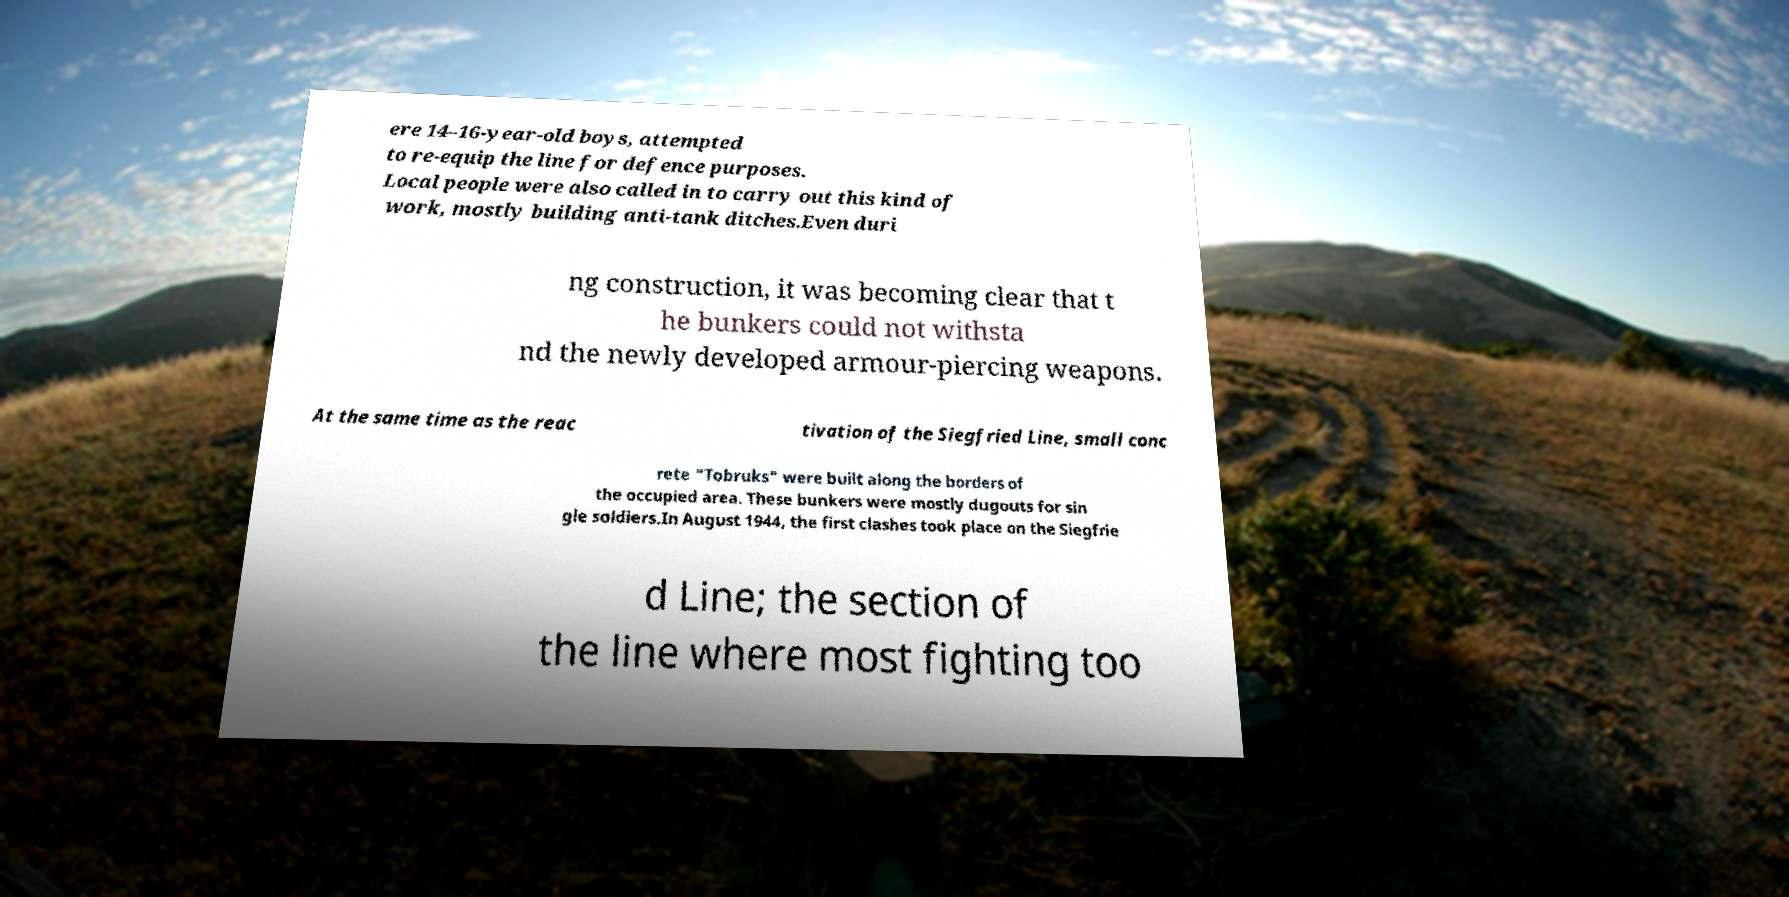Could you assist in decoding the text presented in this image and type it out clearly? ere 14–16-year-old boys, attempted to re-equip the line for defence purposes. Local people were also called in to carry out this kind of work, mostly building anti-tank ditches.Even duri ng construction, it was becoming clear that t he bunkers could not withsta nd the newly developed armour-piercing weapons. At the same time as the reac tivation of the Siegfried Line, small conc rete "Tobruks" were built along the borders of the occupied area. These bunkers were mostly dugouts for sin gle soldiers.In August 1944, the first clashes took place on the Siegfrie d Line; the section of the line where most fighting too 